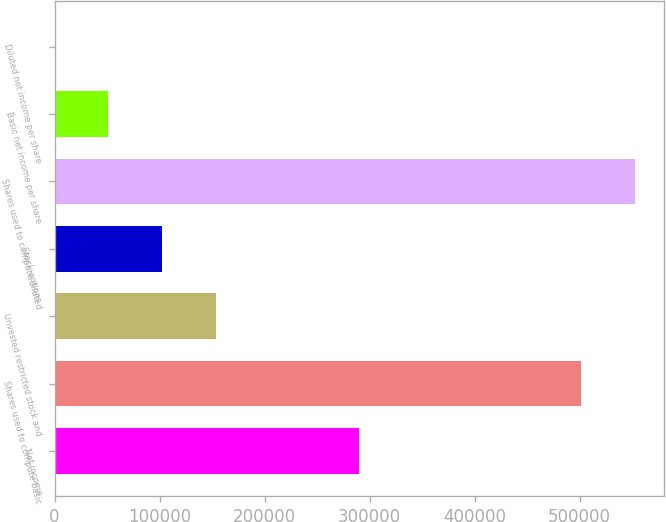<chart> <loc_0><loc_0><loc_500><loc_500><bar_chart><fcel>Net income<fcel>Shares used to compute basic<fcel>Unvested restricted stock and<fcel>Stock options<fcel>Shares used to compute diluted<fcel>Basic net income per share<fcel>Diluted net income per share<nl><fcel>289985<fcel>501372<fcel>154043<fcel>102696<fcel>552720<fcel>51348.1<fcel>0.56<nl></chart> 